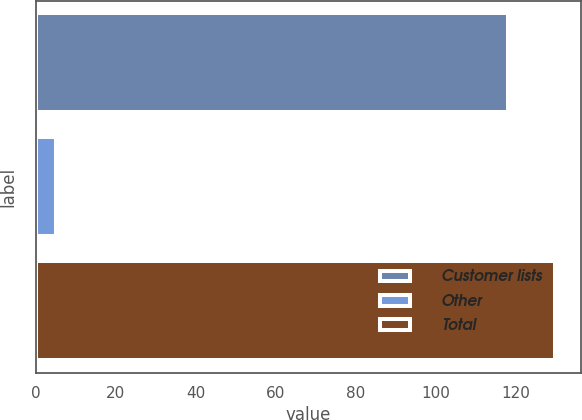<chart> <loc_0><loc_0><loc_500><loc_500><bar_chart><fcel>Customer lists<fcel>Other<fcel>Total<nl><fcel>118<fcel>5<fcel>129.8<nl></chart> 